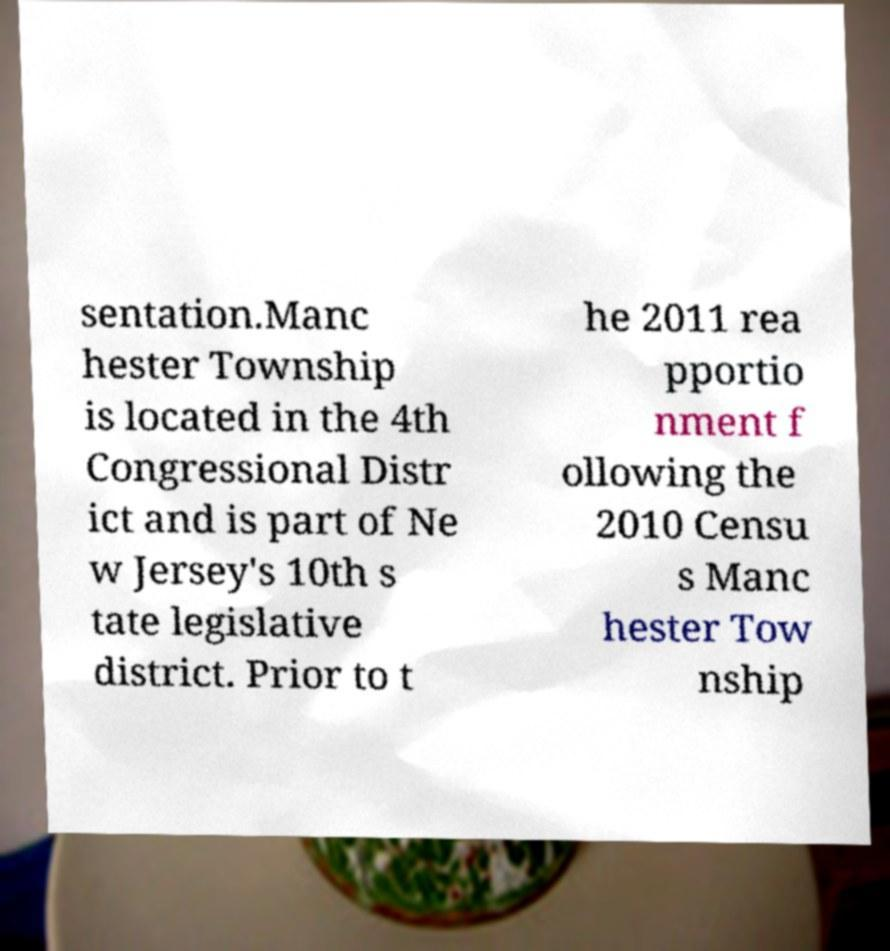There's text embedded in this image that I need extracted. Can you transcribe it verbatim? sentation.Manc hester Township is located in the 4th Congressional Distr ict and is part of Ne w Jersey's 10th s tate legislative district. Prior to t he 2011 rea pportio nment f ollowing the 2010 Censu s Manc hester Tow nship 